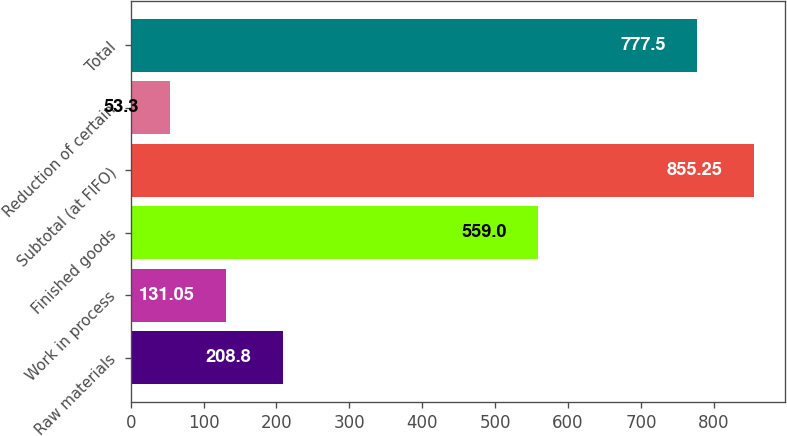<chart> <loc_0><loc_0><loc_500><loc_500><bar_chart><fcel>Raw materials<fcel>Work in process<fcel>Finished goods<fcel>Subtotal (at FIFO)<fcel>Reduction of certain<fcel>Total<nl><fcel>208.8<fcel>131.05<fcel>559<fcel>855.25<fcel>53.3<fcel>777.5<nl></chart> 